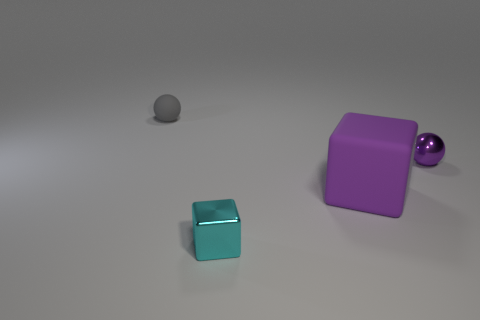What is the lighting condition in the scene? The scene is softly illuminated, likely by an overhead light source, providing a subtle shadow below each object which hints at their three-dimensional form.  Are there any other objects in the image besides the small matte sphere and the small purple metallic cube? Indeed, there are. Apart from the small matte sphere and the small purple metallic cube, there's a larger purple cube and a blue metallic box with what appears to be a reflective surface. 